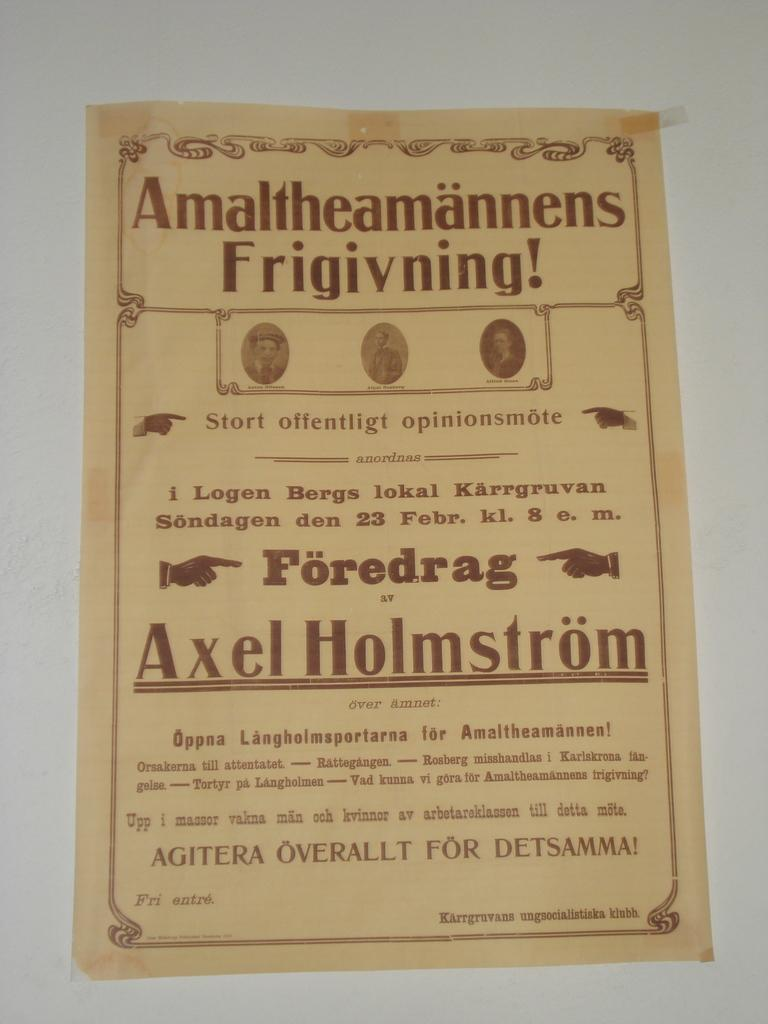<image>
Give a short and clear explanation of the subsequent image. A yellowed piece of paper with brownish red writing and the name Axel Holmstrom 